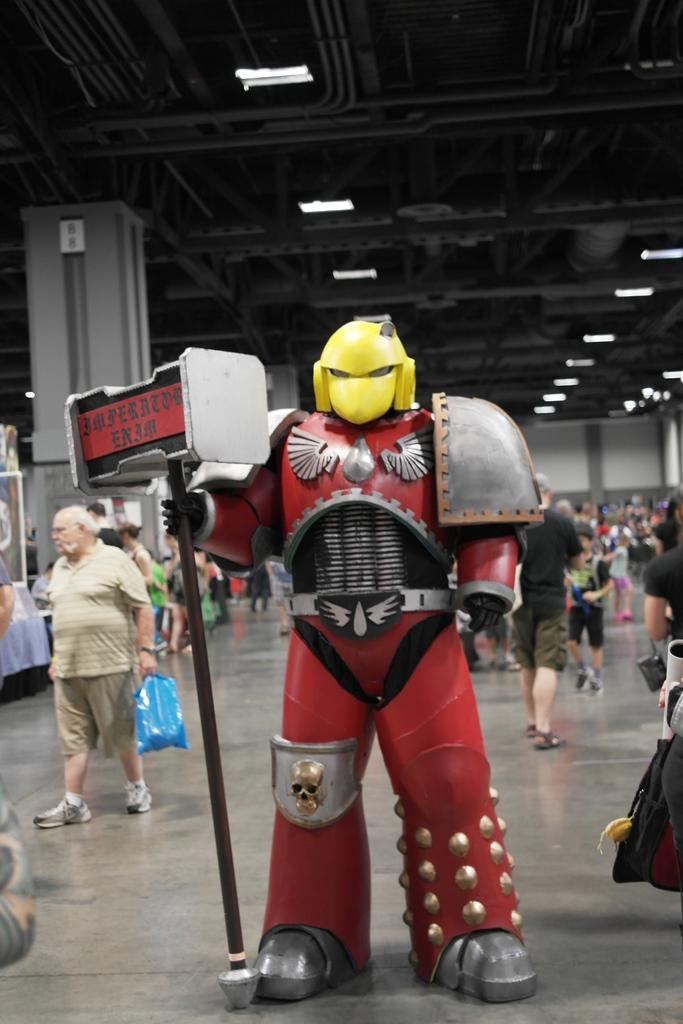What is the main subject in the middle of the image? There is a doll in the middle of the image. What can be seen happening in the background of the image? There are people working in the background of the image. What is visible at the top of the image? There are lights visible at the top of the image. What type of reward is the doll holding in the image? There is no reward present in the image; it is a doll in the middle of the image. What kind of metal is used to make the doll in the image? The facts provided do not mention the material used to make the doll, so we cannot determine if it is made of metal or any other material. 